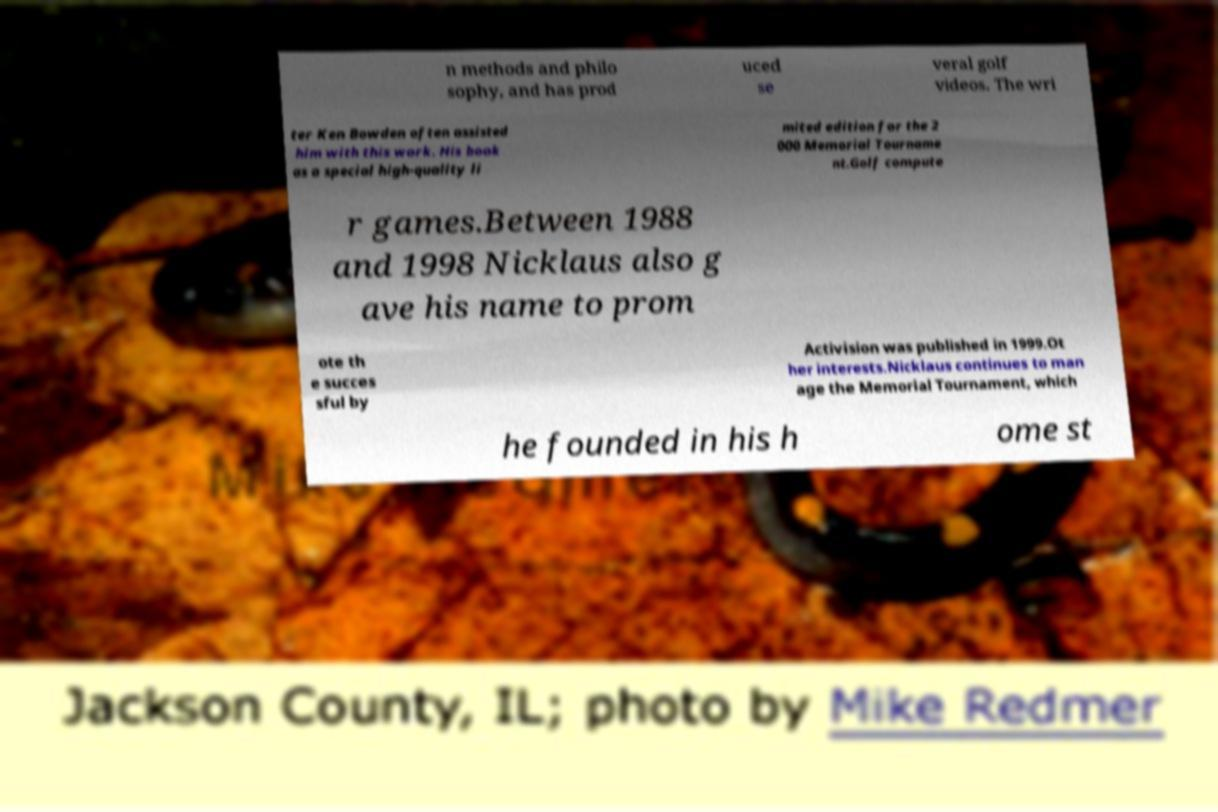Please read and relay the text visible in this image. What does it say? n methods and philo sophy, and has prod uced se veral golf videos. The wri ter Ken Bowden often assisted him with this work. His book as a special high-quality li mited edition for the 2 000 Memorial Tourname nt.Golf compute r games.Between 1988 and 1998 Nicklaus also g ave his name to prom ote th e succes sful by Activision was published in 1999.Ot her interests.Nicklaus continues to man age the Memorial Tournament, which he founded in his h ome st 